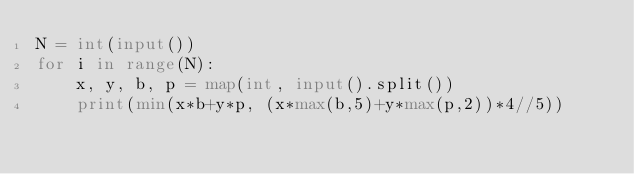Convert code to text. <code><loc_0><loc_0><loc_500><loc_500><_Python_>N = int(input())
for i in range(N):
    x, y, b, p = map(int, input().split())
    print(min(x*b+y*p, (x*max(b,5)+y*max(p,2))*4//5))
</code> 